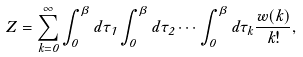Convert formula to latex. <formula><loc_0><loc_0><loc_500><loc_500>Z = \sum _ { k = 0 } ^ { \infty } \int _ { 0 } ^ { \beta } d \tau _ { 1 } \int _ { 0 } ^ { \beta } d \tau _ { 2 } \cdots \int _ { 0 } ^ { \beta } d \tau _ { k } \frac { w ( k ) } { k ! } ,</formula> 